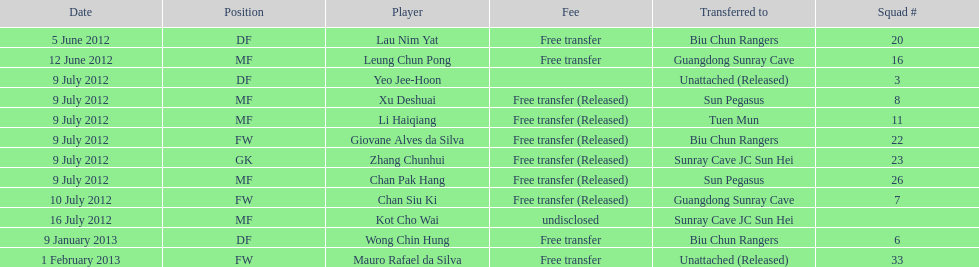Who is the first player listed? Lau Nim Yat. 